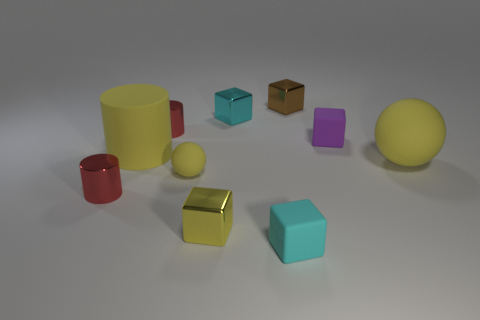There is a small purple object; are there any tiny cylinders right of it?
Your answer should be compact. No. There is a metal thing that is behind the tiny purple rubber cube and to the left of the tiny cyan shiny cube; what is its color?
Provide a short and direct response. Red. Is there a tiny ball of the same color as the big rubber sphere?
Make the answer very short. Yes. Does the small cyan cube that is behind the tiny yellow matte thing have the same material as the tiny cylinder that is behind the large yellow rubber sphere?
Offer a very short reply. Yes. There is a yellow matte sphere that is on the right side of the tiny yellow shiny block; what is its size?
Your answer should be very brief. Large. What size is the purple rubber block?
Your answer should be compact. Small. There is a red shiny cylinder that is in front of the big yellow matte thing to the left of the small metallic block that is left of the cyan metallic thing; what is its size?
Provide a succinct answer. Small. Are there any small brown things made of the same material as the purple block?
Give a very brief answer. No. There is a small brown object; what shape is it?
Make the answer very short. Cube. The tiny sphere that is the same material as the small purple cube is what color?
Ensure brevity in your answer.  Yellow. 